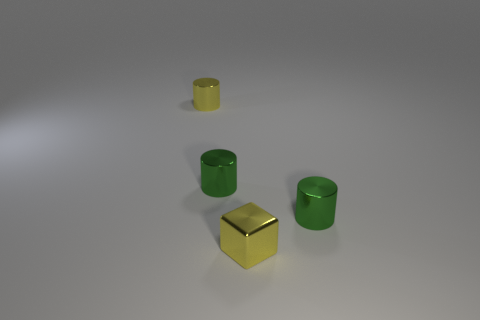How many yellow metal objects have the same size as the block?
Make the answer very short. 1. Does the small yellow object to the right of the small yellow cylinder have the same material as the small yellow cylinder that is on the left side of the small metallic cube?
Your answer should be very brief. Yes. The green cylinder to the right of the green object that is to the left of the metal block is made of what material?
Your response must be concise. Metal. There is a tiny yellow object behind the small yellow block; what material is it?
Make the answer very short. Metal. The cylinder that is to the right of the yellow metal thing in front of the small metal cylinder right of the metallic cube is made of what material?
Ensure brevity in your answer.  Metal. There is a tiny block; are there any tiny cylinders in front of it?
Keep it short and to the point. No. What is the shape of the yellow object that is the same size as the yellow shiny cube?
Keep it short and to the point. Cylinder. Are the yellow cylinder and the tiny yellow cube made of the same material?
Keep it short and to the point. Yes. How many metal objects are either yellow cylinders or big balls?
Ensure brevity in your answer.  1. There is a thing that is the same color as the cube; what shape is it?
Keep it short and to the point. Cylinder. 